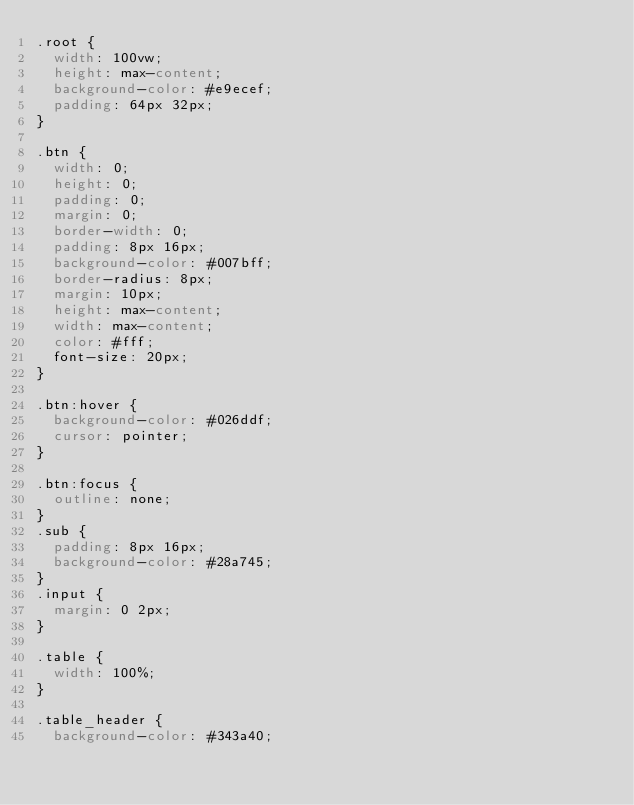<code> <loc_0><loc_0><loc_500><loc_500><_CSS_>.root {
  width: 100vw;
  height: max-content;
  background-color: #e9ecef;
  padding: 64px 32px;
}

.btn {
  width: 0;
  height: 0;
  padding: 0;
  margin: 0;
  border-width: 0;
  padding: 8px 16px;
  background-color: #007bff;
  border-radius: 8px;
  margin: 10px;
  height: max-content;
  width: max-content;
  color: #fff;
  font-size: 20px;
}

.btn:hover {
  background-color: #026ddf;
  cursor: pointer;
}

.btn:focus {
  outline: none;
}
.sub {
  padding: 8px 16px;
  background-color: #28a745;
}
.input {
  margin: 0 2px;
}

.table {
  width: 100%;
}

.table_header {
  background-color: #343a40;</code> 